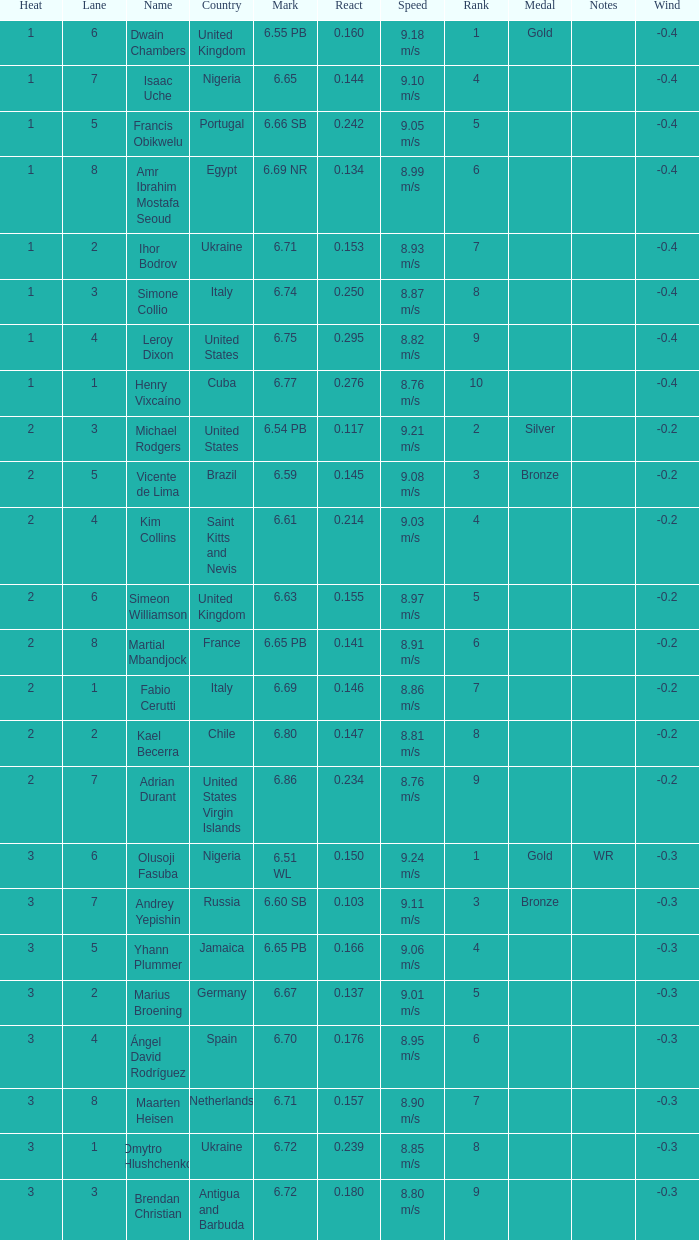What is Heat, when Mark is 6.69? 2.0. Parse the table in full. {'header': ['Heat', 'Lane', 'Name', 'Country', 'Mark', 'React', 'Speed', 'Rank', 'Medal', 'Notes', 'Wind'], 'rows': [['1', '6', 'Dwain Chambers', 'United Kingdom', '6.55 PB', '0.160', '9.18 m/s', '1', 'Gold', '', '-0.4'], ['1', '7', 'Isaac Uche', 'Nigeria', '6.65', '0.144', '9.10 m/s', '4', '', '', '-0.4'], ['1', '5', 'Francis Obikwelu', 'Portugal', '6.66 SB', '0.242', '9.05 m/s', '5', '', '', '-0.4'], ['1', '8', 'Amr Ibrahim Mostafa Seoud', 'Egypt', '6.69 NR', '0.134', '8.99 m/s', '6', '', '', '-0.4'], ['1', '2', 'Ihor Bodrov', 'Ukraine', '6.71', '0.153', '8.93 m/s', '7', '', '', '-0.4'], ['1', '3', 'Simone Collio', 'Italy', '6.74', '0.250', '8.87 m/s', '8', '', '', '-0.4'], ['1', '4', 'Leroy Dixon', 'United States', '6.75', '0.295', '8.82 m/s', '9', '', '', '-0.4'], ['1', '1', 'Henry Vixcaíno', 'Cuba', '6.77', '0.276', '8.76 m/s', '10', '', '', '-0.4'], ['2', '3', 'Michael Rodgers', 'United States', '6.54 PB', '0.117', '9.21 m/s', '2', 'Silver', '', '-0.2'], ['2', '5', 'Vicente de Lima', 'Brazil', '6.59', '0.145', '9.08 m/s', '3', 'Bronze', '', '-0.2'], ['2', '4', 'Kim Collins', 'Saint Kitts and Nevis', '6.61', '0.214', '9.03 m/s', '4', '', '', '-0.2'], ['2', '6', 'Simeon Williamson', 'United Kingdom', '6.63', '0.155', '8.97 m/s', '5', '', '', '-0.2'], ['2', '8', 'Martial Mbandjock', 'France', '6.65 PB', '0.141', '8.91 m/s', '6', '', '', '-0.2'], ['2', '1', 'Fabio Cerutti', 'Italy', '6.69', '0.146', '8.86 m/s', '7', '', '', '-0.2'], ['2', '2', 'Kael Becerra', 'Chile', '6.80', '0.147', '8.81 m/s', '8', '', '', '-0.2'], ['2', '7', 'Adrian Durant', 'United States Virgin Islands', '6.86', '0.234', '8.76 m/s', '9', '', '', '-0.2'], ['3', '6', 'Olusoji Fasuba', 'Nigeria', '6.51 WL', '0.150', '9.24 m/s', '1', 'Gold', 'WR', '-0.3'], ['3', '7', 'Andrey Yepishin', 'Russia', '6.60 SB', '0.103', '9.11 m/s', '3', 'Bronze', '', '-0.3'], ['3', '5', 'Yhann Plummer', 'Jamaica', '6.65 PB', '0.166', '9.06 m/s', '4', '', '', '-0.3'], ['3', '2', 'Marius Broening', 'Germany', '6.67', '0.137', '9.01 m/s', '5', '', '', '-0.3'], ['3', '4', 'Ángel David Rodríguez', 'Spain', '6.70', '0.176', '8.95 m/s', '6', '', '', '-0.3'], ['3', '8', 'Maarten Heisen', 'Netherlands', '6.71', '0.157', '8.90 m/s', '7', '', '', '-0.3'], ['3', '1', 'Dmytro Hlushchenko', 'Ukraine', '6.72', '0.239', '8.85 m/s', '8', '', '', '-0.3'], ['3', '3', 'Brendan Christian', 'Antigua and Barbuda', '6.72', '0.180', '8.80 m/s', '9', '', '', '-0.3']]} 